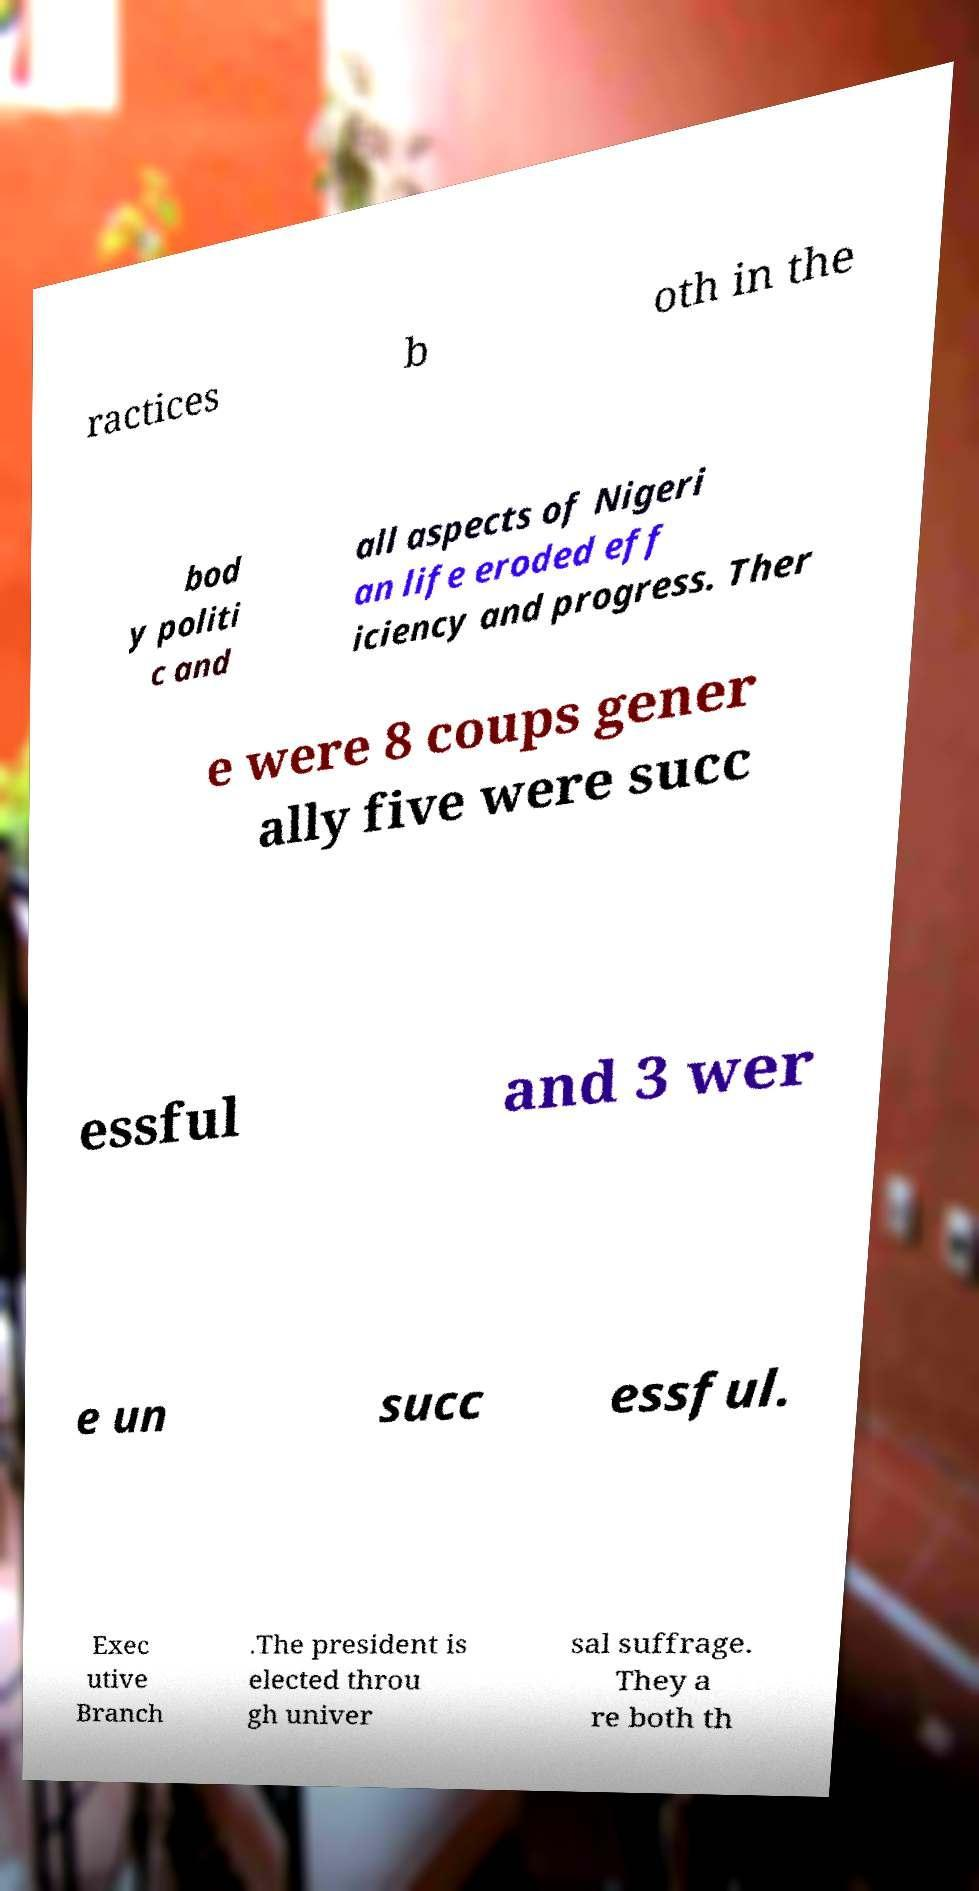Please identify and transcribe the text found in this image. ractices b oth in the bod y politi c and all aspects of Nigeri an life eroded eff iciency and progress. Ther e were 8 coups gener ally five were succ essful and 3 wer e un succ essful. Exec utive Branch .The president is elected throu gh univer sal suffrage. They a re both th 